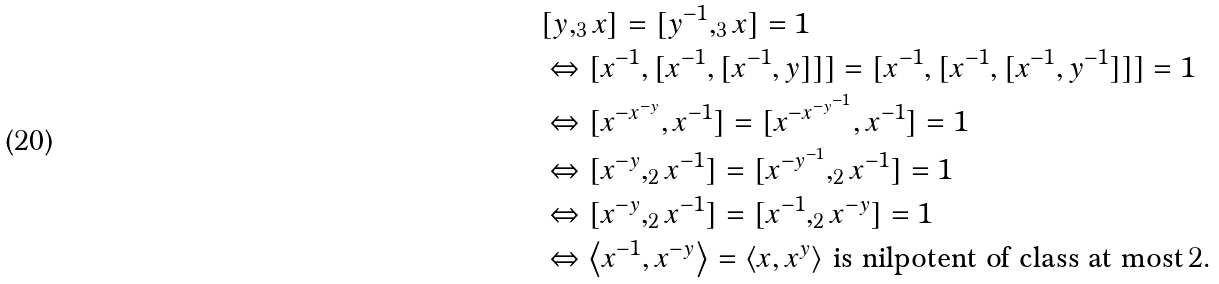Convert formula to latex. <formula><loc_0><loc_0><loc_500><loc_500>& [ y , _ { 3 } x ] = [ y ^ { - 1 } , _ { 3 } x ] = 1 \\ & \Leftrightarrow [ x ^ { - 1 } , [ x ^ { - 1 } , [ x ^ { - 1 } , y ] ] ] = [ x ^ { - 1 } , [ x ^ { - 1 } , [ x ^ { - 1 } , y ^ { - 1 } ] ] ] = 1 \\ & \Leftrightarrow [ x ^ { - x ^ { - y } } , x ^ { - 1 } ] = [ x ^ { - x ^ { - y ^ { - 1 } } } , x ^ { - 1 } ] = 1 \\ & \Leftrightarrow [ x ^ { - y } , _ { 2 } x ^ { - 1 } ] = [ x ^ { - y ^ { - 1 } } , _ { 2 } x ^ { - 1 } ] = 1 \\ & \Leftrightarrow [ x ^ { - y } , _ { 2 } x ^ { - 1 } ] = [ x ^ { - 1 } , _ { 2 } x ^ { - y } ] = 1 \\ & \Leftrightarrow \left < x ^ { - 1 } , x ^ { - y } \right > = \left < x , x ^ { y } \right > \, \text {is nilpotent of class at most} \, 2 .</formula> 